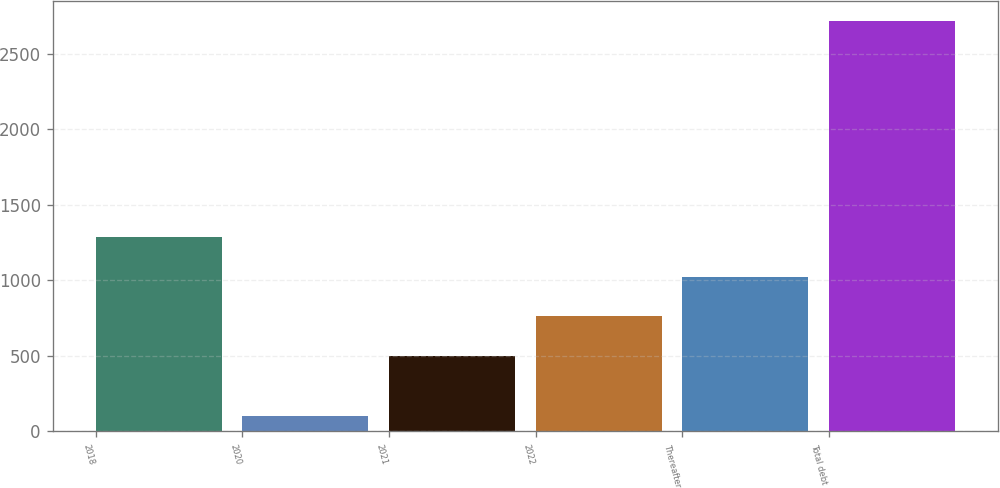<chart> <loc_0><loc_0><loc_500><loc_500><bar_chart><fcel>2018<fcel>2020<fcel>2021<fcel>2022<fcel>Thereafter<fcel>Total debt<nl><fcel>1284.59<fcel>100<fcel>500<fcel>761.53<fcel>1023.06<fcel>2715.3<nl></chart> 